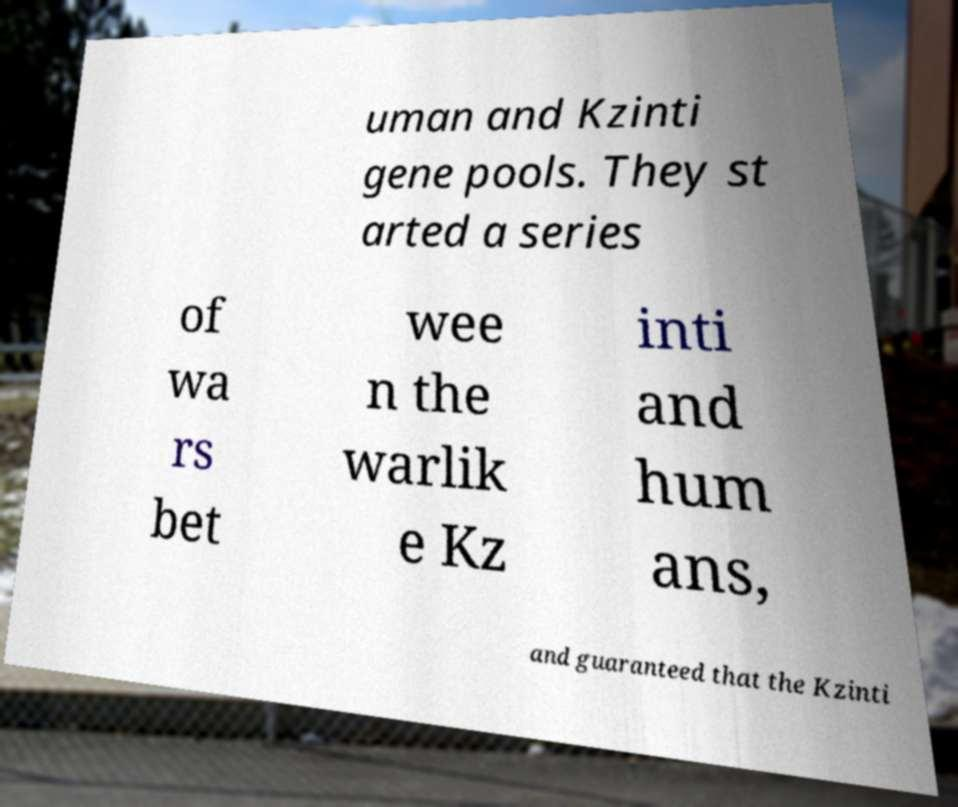Please identify and transcribe the text found in this image. uman and Kzinti gene pools. They st arted a series of wa rs bet wee n the warlik e Kz inti and hum ans, and guaranteed that the Kzinti 